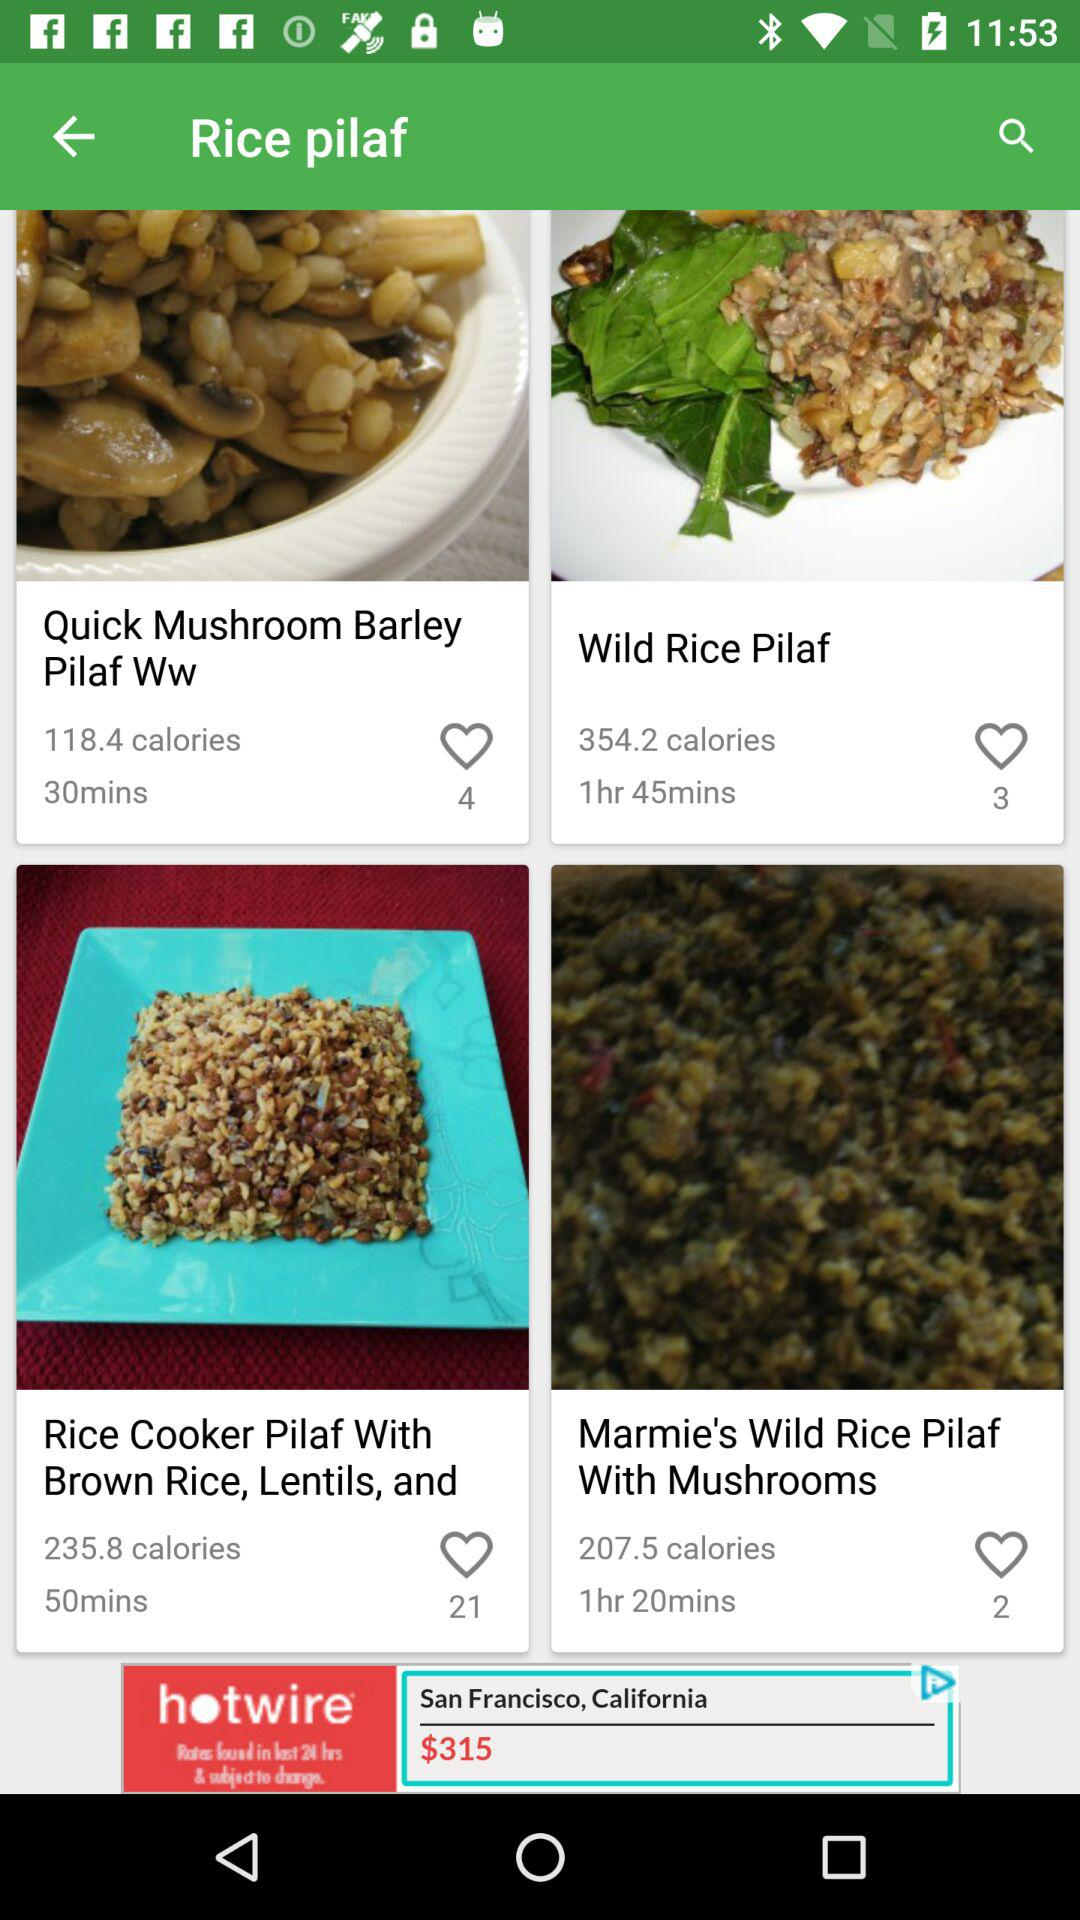What is the number of likes on "Wild Rice Pilaf"? There are three likes. 